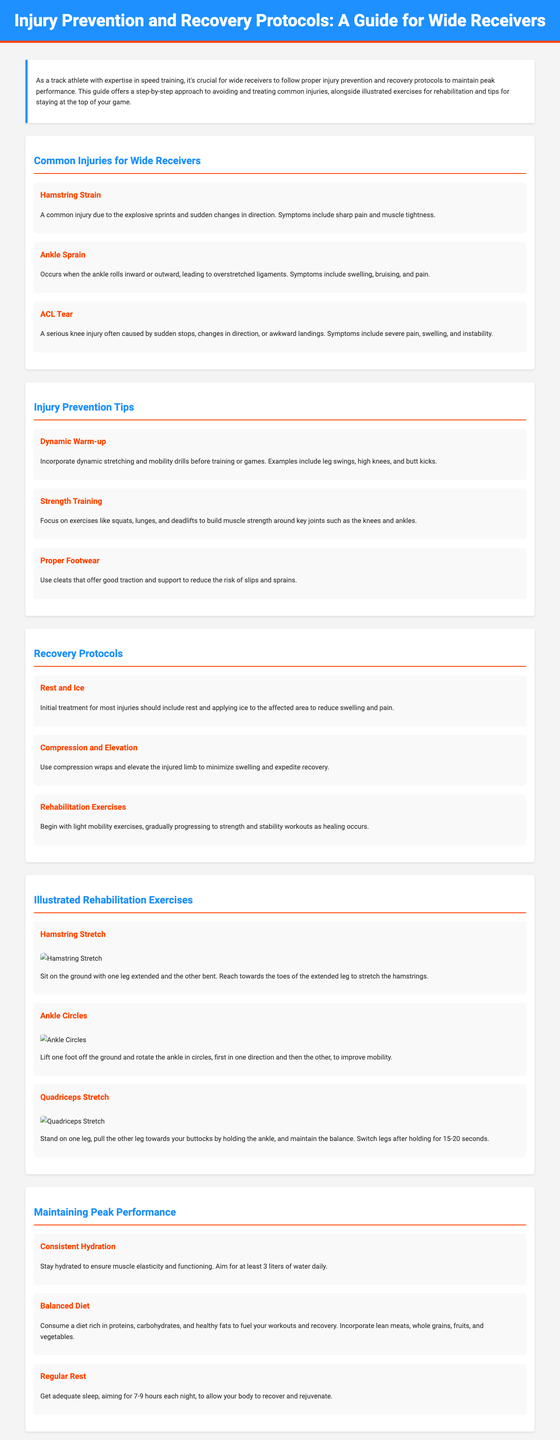What is the title of the guide? The title is the main heading found at the top of the document, which outlines the content.
Answer: Injury Prevention and Recovery Protocols: A Guide for Wide Receivers How many common injuries are listed in the document? There are three common injuries mentioned in the section dedicated to them.
Answer: 3 What is one recommended injury prevention tip? This information can be found in the injury prevention tips section, which highlights strategies to reduce injury risk.
Answer: Dynamic Warm-up What is the first step in the recovery protocol? This is the first of the steps outlined in the recovery protocols section of the document.
Answer: Rest and Ice Which exercise is used to improve ankle mobility? The exercise specifically aimed at enhancing ankle movement is detailed under the illustrated rehabilitation exercises.
Answer: Ankle Circles What is the recommended daily water intake mentioned? This information is found in the tips for maintaining peak performance, emphasizing hydration.
Answer: 3 liters How many rehabilitation exercises are illustrated in the document? The section on illustrated rehabilitation exercises contains details about multiple exercises.
Answer: 3 What is suggested for maintaining sleep quality? The document provides a specific recommendation regarding sleep duration in the section on peak performance.
Answer: 7-9 hours What is a key component of a balanced diet according to the guide? The guide outlines essential dietary components that support athletic performance and recovery.
Answer: Proteins 